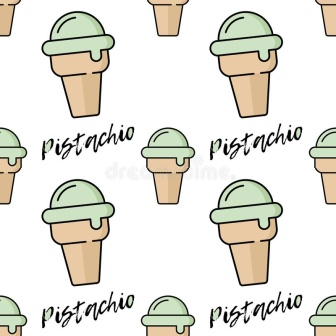Write a poem inspired by this image. In a field of cones, where dreams are sweet,
Pistachio whispers, a silent treat.
Green scoops glisten in light brown bowls,
Bearing stories that warm the soul.
Amidst the grid of pure delight,
Pistachio calls in the day and night.
Savor the sight, the taste, the way,
Each cone promises a blissful day. 